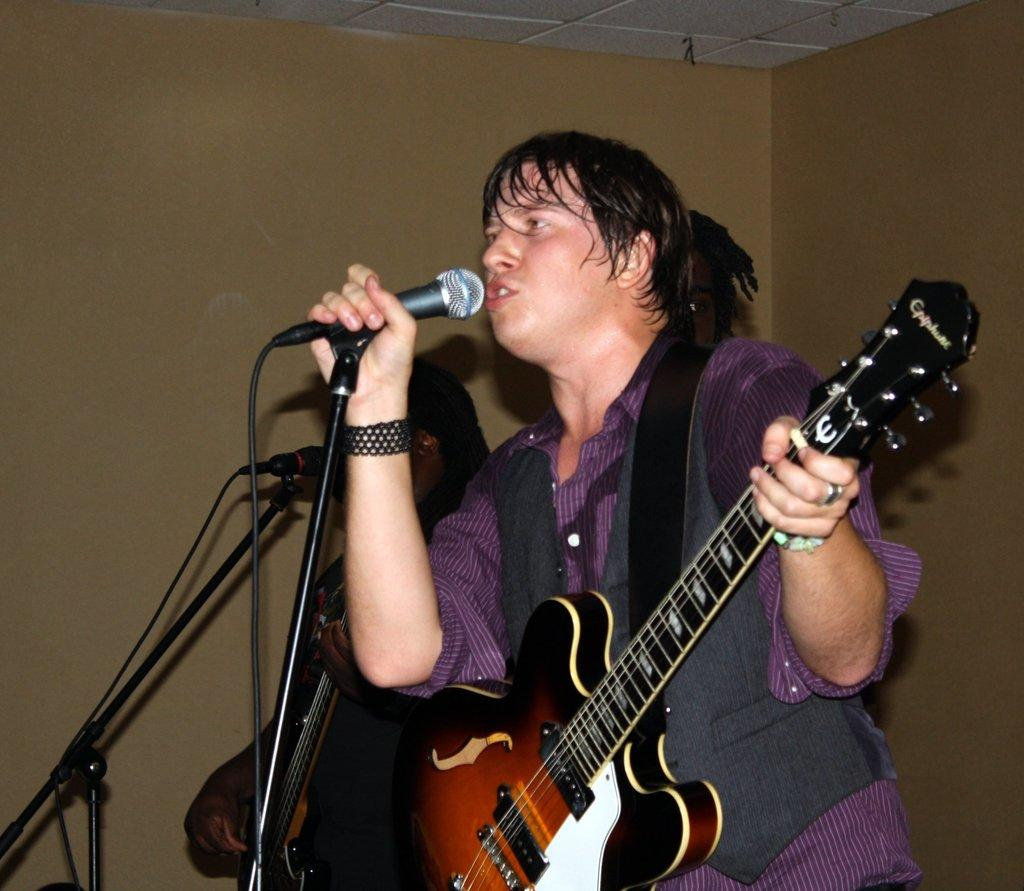What is the main subject of the image? There is a person in the image. What is the person doing in the image? The person is standing in the image. What object is the person holding in the image? The person is holding a guitar in the image. What can be seen behind the person in the image? There is a wall behind the person in the image. What type of cord is wrapped around the person's neck in the image? There is no cord wrapped around the person's neck in the image. What decision did the person make before holding the guitar in the image? The image does not provide information about any decisions made by the person before holding the guitar. 